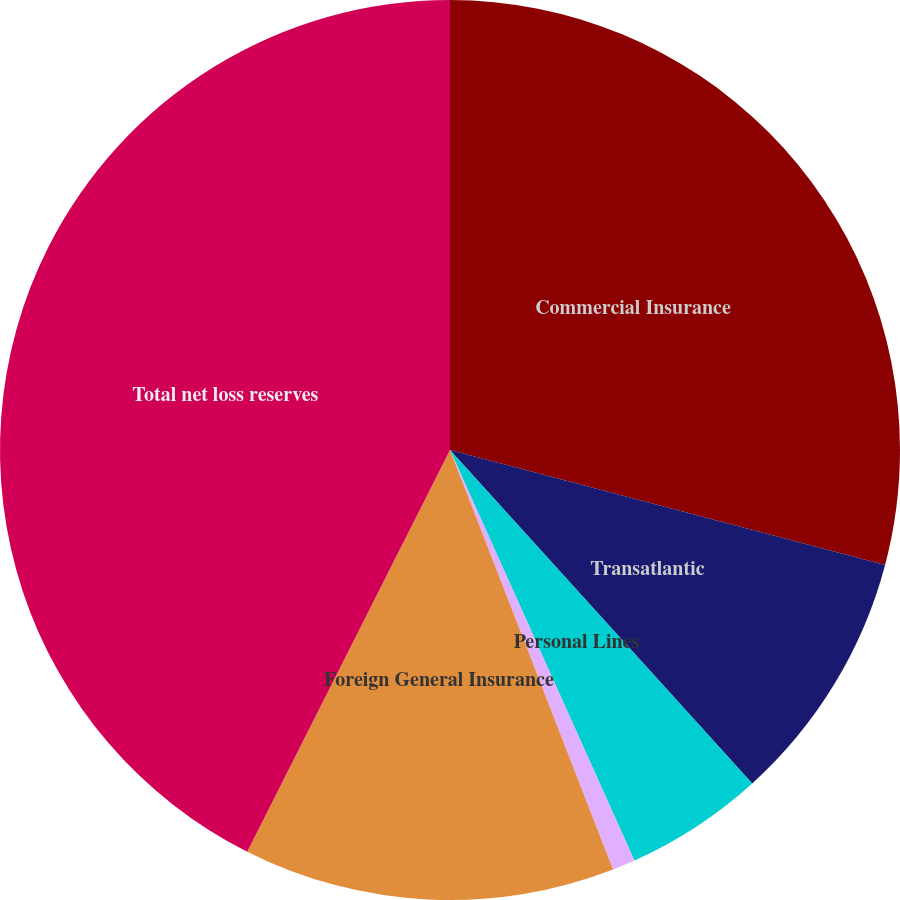Convert chart. <chart><loc_0><loc_0><loc_500><loc_500><pie_chart><fcel>Commercial Insurance<fcel>Transatlantic<fcel>Personal Lines<fcel>Mortgage Guaranty<fcel>Foreign General Insurance<fcel>Total net loss reserves<nl><fcel>29.11%<fcel>9.17%<fcel>5.0%<fcel>0.82%<fcel>13.34%<fcel>42.56%<nl></chart> 